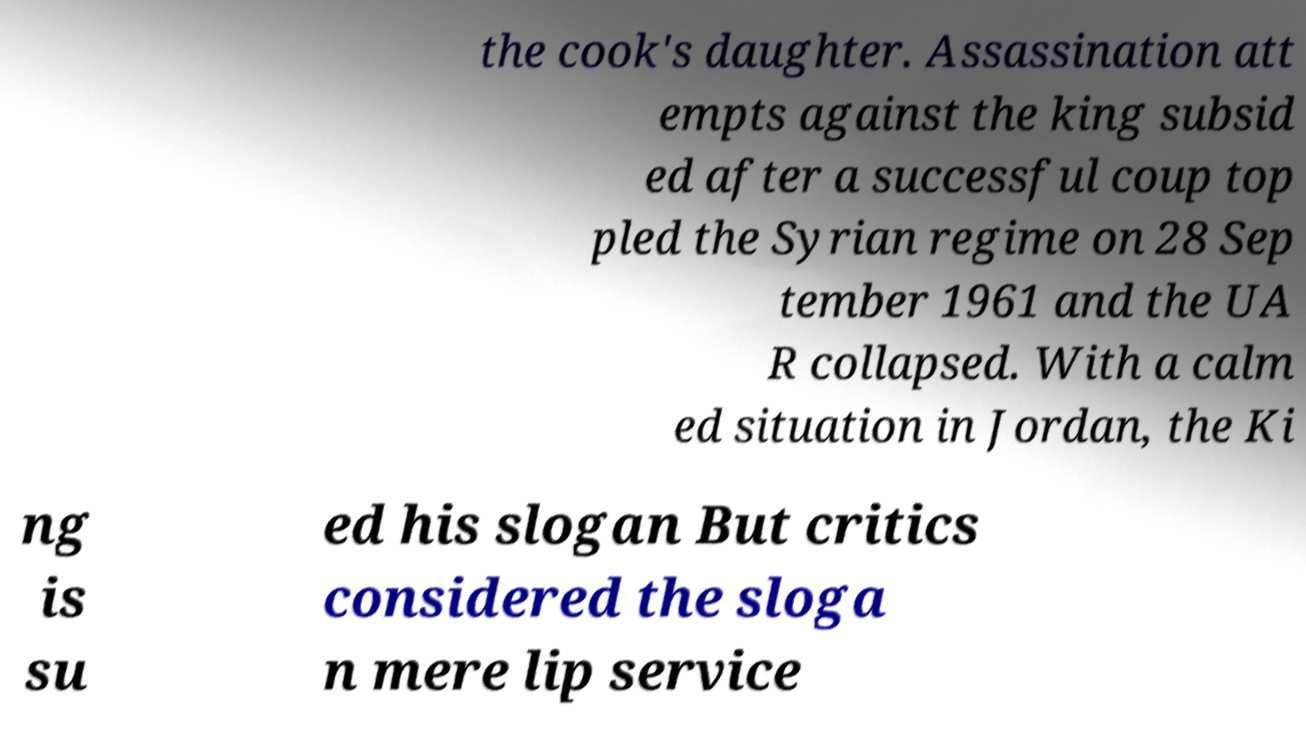Please identify and transcribe the text found in this image. the cook's daughter. Assassination att empts against the king subsid ed after a successful coup top pled the Syrian regime on 28 Sep tember 1961 and the UA R collapsed. With a calm ed situation in Jordan, the Ki ng is su ed his slogan But critics considered the sloga n mere lip service 